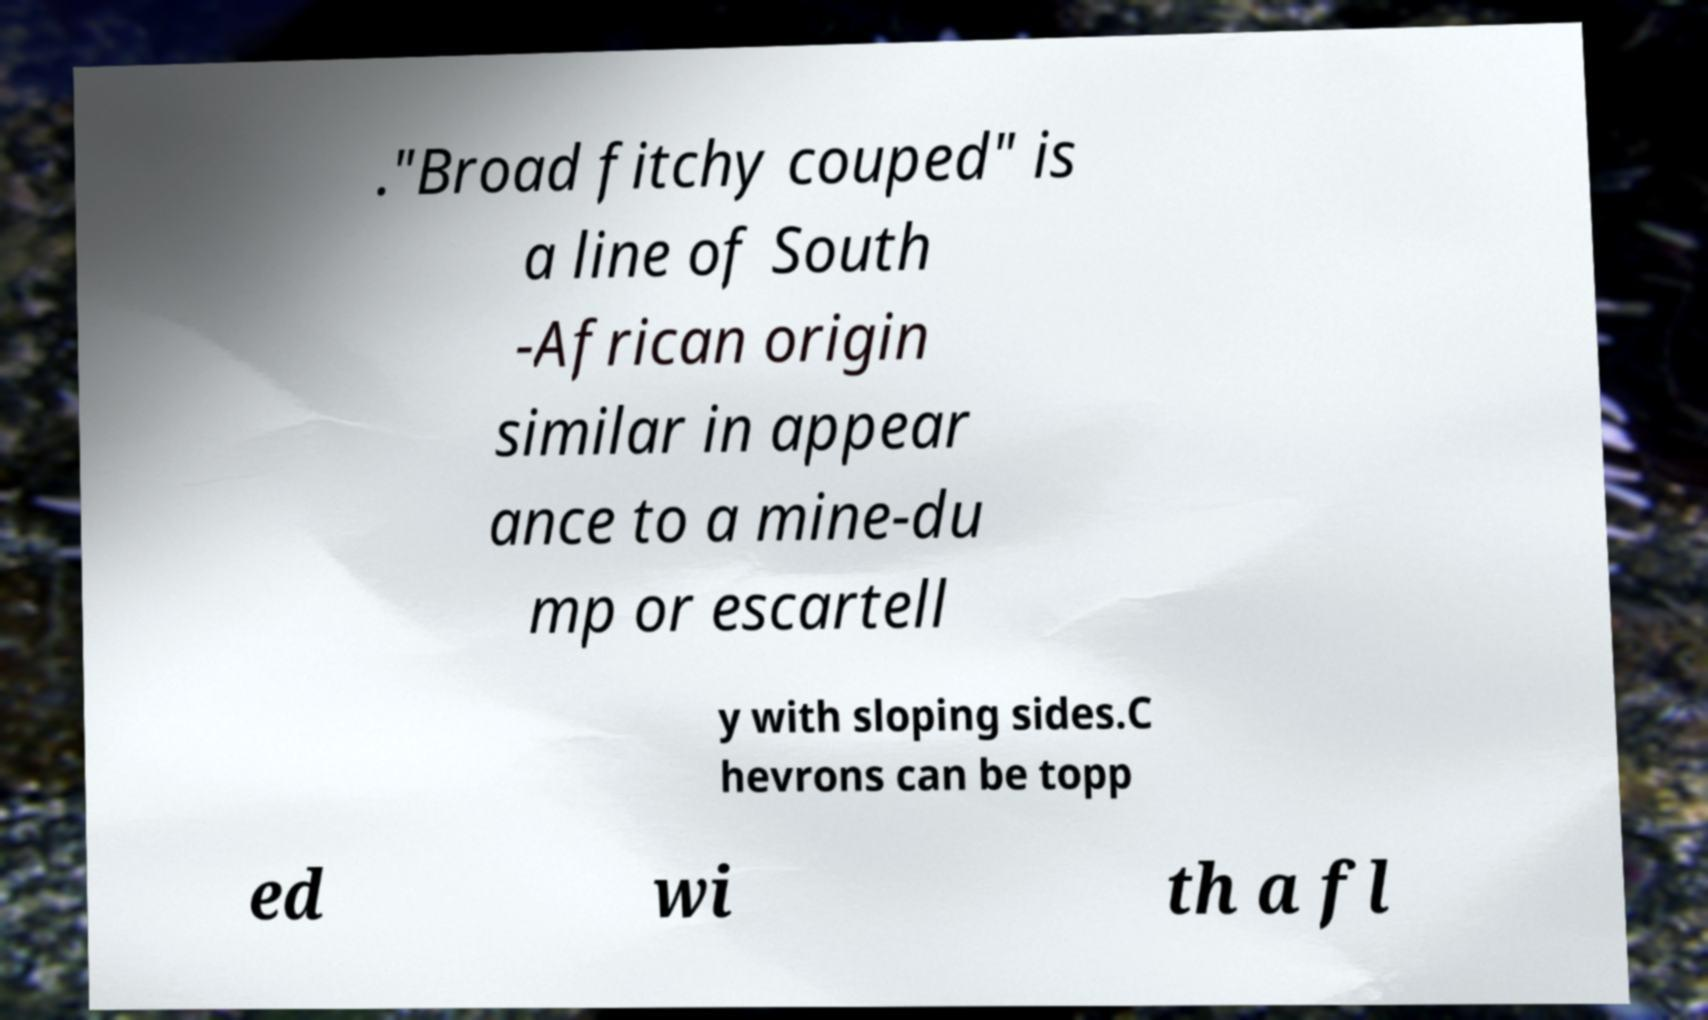For documentation purposes, I need the text within this image transcribed. Could you provide that? ."Broad fitchy couped" is a line of South -African origin similar in appear ance to a mine-du mp or escartell y with sloping sides.C hevrons can be topp ed wi th a fl 